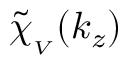Convert formula to latex. <formula><loc_0><loc_0><loc_500><loc_500>\ m a t h i n n e r { \tilde { \chi } _ { _ { V } } \left ( k _ { z } \right ) }</formula> 